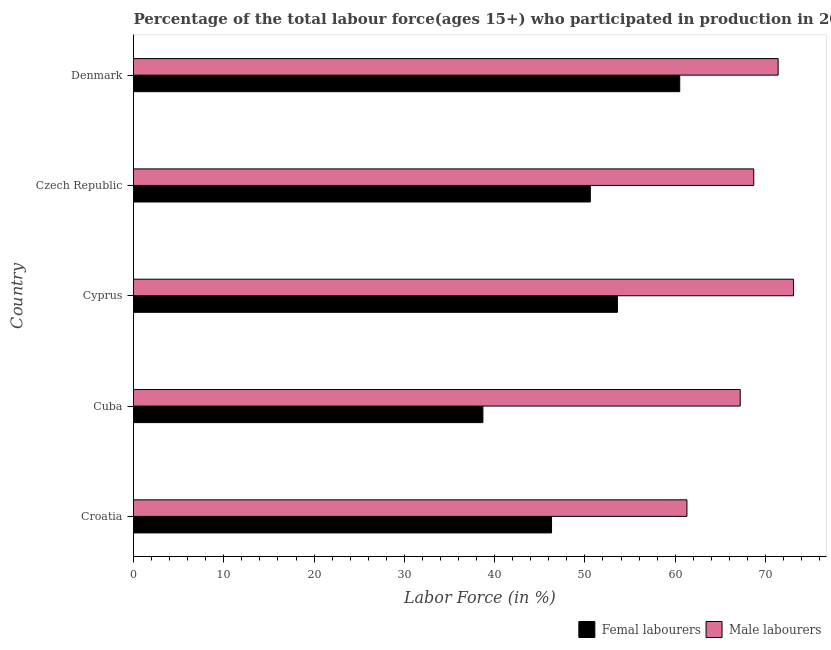How many bars are there on the 5th tick from the top?
Provide a succinct answer. 2. How many bars are there on the 5th tick from the bottom?
Provide a short and direct response. 2. What is the label of the 4th group of bars from the top?
Give a very brief answer. Cuba. In how many cases, is the number of bars for a given country not equal to the number of legend labels?
Ensure brevity in your answer.  0. What is the percentage of male labour force in Denmark?
Your answer should be very brief. 71.4. Across all countries, what is the maximum percentage of female labor force?
Your answer should be very brief. 60.5. Across all countries, what is the minimum percentage of female labor force?
Your answer should be very brief. 38.7. In which country was the percentage of male labour force maximum?
Give a very brief answer. Cyprus. In which country was the percentage of male labour force minimum?
Your response must be concise. Croatia. What is the total percentage of male labour force in the graph?
Ensure brevity in your answer.  341.7. What is the difference between the percentage of male labour force in Croatia and the percentage of female labor force in Cuba?
Ensure brevity in your answer.  22.6. What is the average percentage of female labor force per country?
Give a very brief answer. 49.94. What is the difference between the percentage of female labor force and percentage of male labour force in Cuba?
Ensure brevity in your answer.  -28.5. What is the ratio of the percentage of female labor force in Croatia to that in Czech Republic?
Offer a very short reply. 0.92. What is the difference between the highest and the lowest percentage of female labor force?
Keep it short and to the point. 21.8. Is the sum of the percentage of female labor force in Croatia and Denmark greater than the maximum percentage of male labour force across all countries?
Offer a very short reply. Yes. What does the 1st bar from the top in Croatia represents?
Your answer should be compact. Male labourers. What does the 1st bar from the bottom in Croatia represents?
Ensure brevity in your answer.  Femal labourers. How many bars are there?
Offer a terse response. 10. Are all the bars in the graph horizontal?
Provide a succinct answer. Yes. Does the graph contain any zero values?
Keep it short and to the point. No. Does the graph contain grids?
Your answer should be very brief. No. Where does the legend appear in the graph?
Make the answer very short. Bottom right. How many legend labels are there?
Provide a short and direct response. 2. How are the legend labels stacked?
Offer a very short reply. Horizontal. What is the title of the graph?
Your answer should be compact. Percentage of the total labour force(ages 15+) who participated in production in 2005. What is the label or title of the X-axis?
Offer a very short reply. Labor Force (in %). What is the Labor Force (in %) of Femal labourers in Croatia?
Your answer should be compact. 46.3. What is the Labor Force (in %) in Male labourers in Croatia?
Your answer should be compact. 61.3. What is the Labor Force (in %) in Femal labourers in Cuba?
Your answer should be very brief. 38.7. What is the Labor Force (in %) in Male labourers in Cuba?
Provide a short and direct response. 67.2. What is the Labor Force (in %) of Femal labourers in Cyprus?
Your answer should be very brief. 53.6. What is the Labor Force (in %) of Male labourers in Cyprus?
Ensure brevity in your answer.  73.1. What is the Labor Force (in %) of Femal labourers in Czech Republic?
Give a very brief answer. 50.6. What is the Labor Force (in %) of Male labourers in Czech Republic?
Provide a short and direct response. 68.7. What is the Labor Force (in %) of Femal labourers in Denmark?
Your answer should be compact. 60.5. What is the Labor Force (in %) in Male labourers in Denmark?
Offer a terse response. 71.4. Across all countries, what is the maximum Labor Force (in %) of Femal labourers?
Your answer should be very brief. 60.5. Across all countries, what is the maximum Labor Force (in %) in Male labourers?
Offer a very short reply. 73.1. Across all countries, what is the minimum Labor Force (in %) of Femal labourers?
Give a very brief answer. 38.7. Across all countries, what is the minimum Labor Force (in %) of Male labourers?
Your answer should be compact. 61.3. What is the total Labor Force (in %) in Femal labourers in the graph?
Keep it short and to the point. 249.7. What is the total Labor Force (in %) of Male labourers in the graph?
Your answer should be compact. 341.7. What is the difference between the Labor Force (in %) in Male labourers in Croatia and that in Cuba?
Offer a terse response. -5.9. What is the difference between the Labor Force (in %) in Male labourers in Croatia and that in Czech Republic?
Make the answer very short. -7.4. What is the difference between the Labor Force (in %) in Male labourers in Croatia and that in Denmark?
Ensure brevity in your answer.  -10.1. What is the difference between the Labor Force (in %) of Femal labourers in Cuba and that in Cyprus?
Keep it short and to the point. -14.9. What is the difference between the Labor Force (in %) in Male labourers in Cuba and that in Cyprus?
Your answer should be very brief. -5.9. What is the difference between the Labor Force (in %) in Male labourers in Cuba and that in Czech Republic?
Make the answer very short. -1.5. What is the difference between the Labor Force (in %) in Femal labourers in Cuba and that in Denmark?
Make the answer very short. -21.8. What is the difference between the Labor Force (in %) in Male labourers in Cyprus and that in Czech Republic?
Your response must be concise. 4.4. What is the difference between the Labor Force (in %) of Femal labourers in Cyprus and that in Denmark?
Your answer should be compact. -6.9. What is the difference between the Labor Force (in %) of Male labourers in Cyprus and that in Denmark?
Give a very brief answer. 1.7. What is the difference between the Labor Force (in %) in Femal labourers in Croatia and the Labor Force (in %) in Male labourers in Cuba?
Ensure brevity in your answer.  -20.9. What is the difference between the Labor Force (in %) in Femal labourers in Croatia and the Labor Force (in %) in Male labourers in Cyprus?
Make the answer very short. -26.8. What is the difference between the Labor Force (in %) of Femal labourers in Croatia and the Labor Force (in %) of Male labourers in Czech Republic?
Offer a very short reply. -22.4. What is the difference between the Labor Force (in %) in Femal labourers in Croatia and the Labor Force (in %) in Male labourers in Denmark?
Your answer should be very brief. -25.1. What is the difference between the Labor Force (in %) of Femal labourers in Cuba and the Labor Force (in %) of Male labourers in Cyprus?
Your answer should be very brief. -34.4. What is the difference between the Labor Force (in %) in Femal labourers in Cuba and the Labor Force (in %) in Male labourers in Czech Republic?
Ensure brevity in your answer.  -30. What is the difference between the Labor Force (in %) in Femal labourers in Cuba and the Labor Force (in %) in Male labourers in Denmark?
Ensure brevity in your answer.  -32.7. What is the difference between the Labor Force (in %) of Femal labourers in Cyprus and the Labor Force (in %) of Male labourers in Czech Republic?
Offer a very short reply. -15.1. What is the difference between the Labor Force (in %) of Femal labourers in Cyprus and the Labor Force (in %) of Male labourers in Denmark?
Your answer should be compact. -17.8. What is the difference between the Labor Force (in %) of Femal labourers in Czech Republic and the Labor Force (in %) of Male labourers in Denmark?
Ensure brevity in your answer.  -20.8. What is the average Labor Force (in %) in Femal labourers per country?
Your answer should be compact. 49.94. What is the average Labor Force (in %) in Male labourers per country?
Provide a succinct answer. 68.34. What is the difference between the Labor Force (in %) in Femal labourers and Labor Force (in %) in Male labourers in Croatia?
Provide a short and direct response. -15. What is the difference between the Labor Force (in %) of Femal labourers and Labor Force (in %) of Male labourers in Cuba?
Ensure brevity in your answer.  -28.5. What is the difference between the Labor Force (in %) of Femal labourers and Labor Force (in %) of Male labourers in Cyprus?
Your answer should be very brief. -19.5. What is the difference between the Labor Force (in %) of Femal labourers and Labor Force (in %) of Male labourers in Czech Republic?
Offer a terse response. -18.1. What is the difference between the Labor Force (in %) in Femal labourers and Labor Force (in %) in Male labourers in Denmark?
Make the answer very short. -10.9. What is the ratio of the Labor Force (in %) in Femal labourers in Croatia to that in Cuba?
Offer a terse response. 1.2. What is the ratio of the Labor Force (in %) of Male labourers in Croatia to that in Cuba?
Provide a short and direct response. 0.91. What is the ratio of the Labor Force (in %) in Femal labourers in Croatia to that in Cyprus?
Provide a short and direct response. 0.86. What is the ratio of the Labor Force (in %) of Male labourers in Croatia to that in Cyprus?
Your answer should be compact. 0.84. What is the ratio of the Labor Force (in %) in Femal labourers in Croatia to that in Czech Republic?
Provide a succinct answer. 0.92. What is the ratio of the Labor Force (in %) of Male labourers in Croatia to that in Czech Republic?
Your answer should be compact. 0.89. What is the ratio of the Labor Force (in %) of Femal labourers in Croatia to that in Denmark?
Offer a very short reply. 0.77. What is the ratio of the Labor Force (in %) in Male labourers in Croatia to that in Denmark?
Make the answer very short. 0.86. What is the ratio of the Labor Force (in %) of Femal labourers in Cuba to that in Cyprus?
Keep it short and to the point. 0.72. What is the ratio of the Labor Force (in %) in Male labourers in Cuba to that in Cyprus?
Your answer should be very brief. 0.92. What is the ratio of the Labor Force (in %) of Femal labourers in Cuba to that in Czech Republic?
Offer a terse response. 0.76. What is the ratio of the Labor Force (in %) of Male labourers in Cuba to that in Czech Republic?
Offer a terse response. 0.98. What is the ratio of the Labor Force (in %) in Femal labourers in Cuba to that in Denmark?
Your response must be concise. 0.64. What is the ratio of the Labor Force (in %) of Male labourers in Cuba to that in Denmark?
Provide a short and direct response. 0.94. What is the ratio of the Labor Force (in %) of Femal labourers in Cyprus to that in Czech Republic?
Offer a very short reply. 1.06. What is the ratio of the Labor Force (in %) of Male labourers in Cyprus to that in Czech Republic?
Your answer should be compact. 1.06. What is the ratio of the Labor Force (in %) of Femal labourers in Cyprus to that in Denmark?
Provide a short and direct response. 0.89. What is the ratio of the Labor Force (in %) of Male labourers in Cyprus to that in Denmark?
Your response must be concise. 1.02. What is the ratio of the Labor Force (in %) of Femal labourers in Czech Republic to that in Denmark?
Your response must be concise. 0.84. What is the ratio of the Labor Force (in %) of Male labourers in Czech Republic to that in Denmark?
Your response must be concise. 0.96. What is the difference between the highest and the second highest Labor Force (in %) of Male labourers?
Your answer should be compact. 1.7. What is the difference between the highest and the lowest Labor Force (in %) in Femal labourers?
Keep it short and to the point. 21.8. 